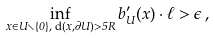<formula> <loc_0><loc_0><loc_500><loc_500>\inf _ { x \in U \smallsetminus \{ 0 \} , \text { d} ( x , \partial U ) > 5 R } b ^ { \prime } _ { U } ( x ) \cdot \ell > \epsilon \, ,</formula> 